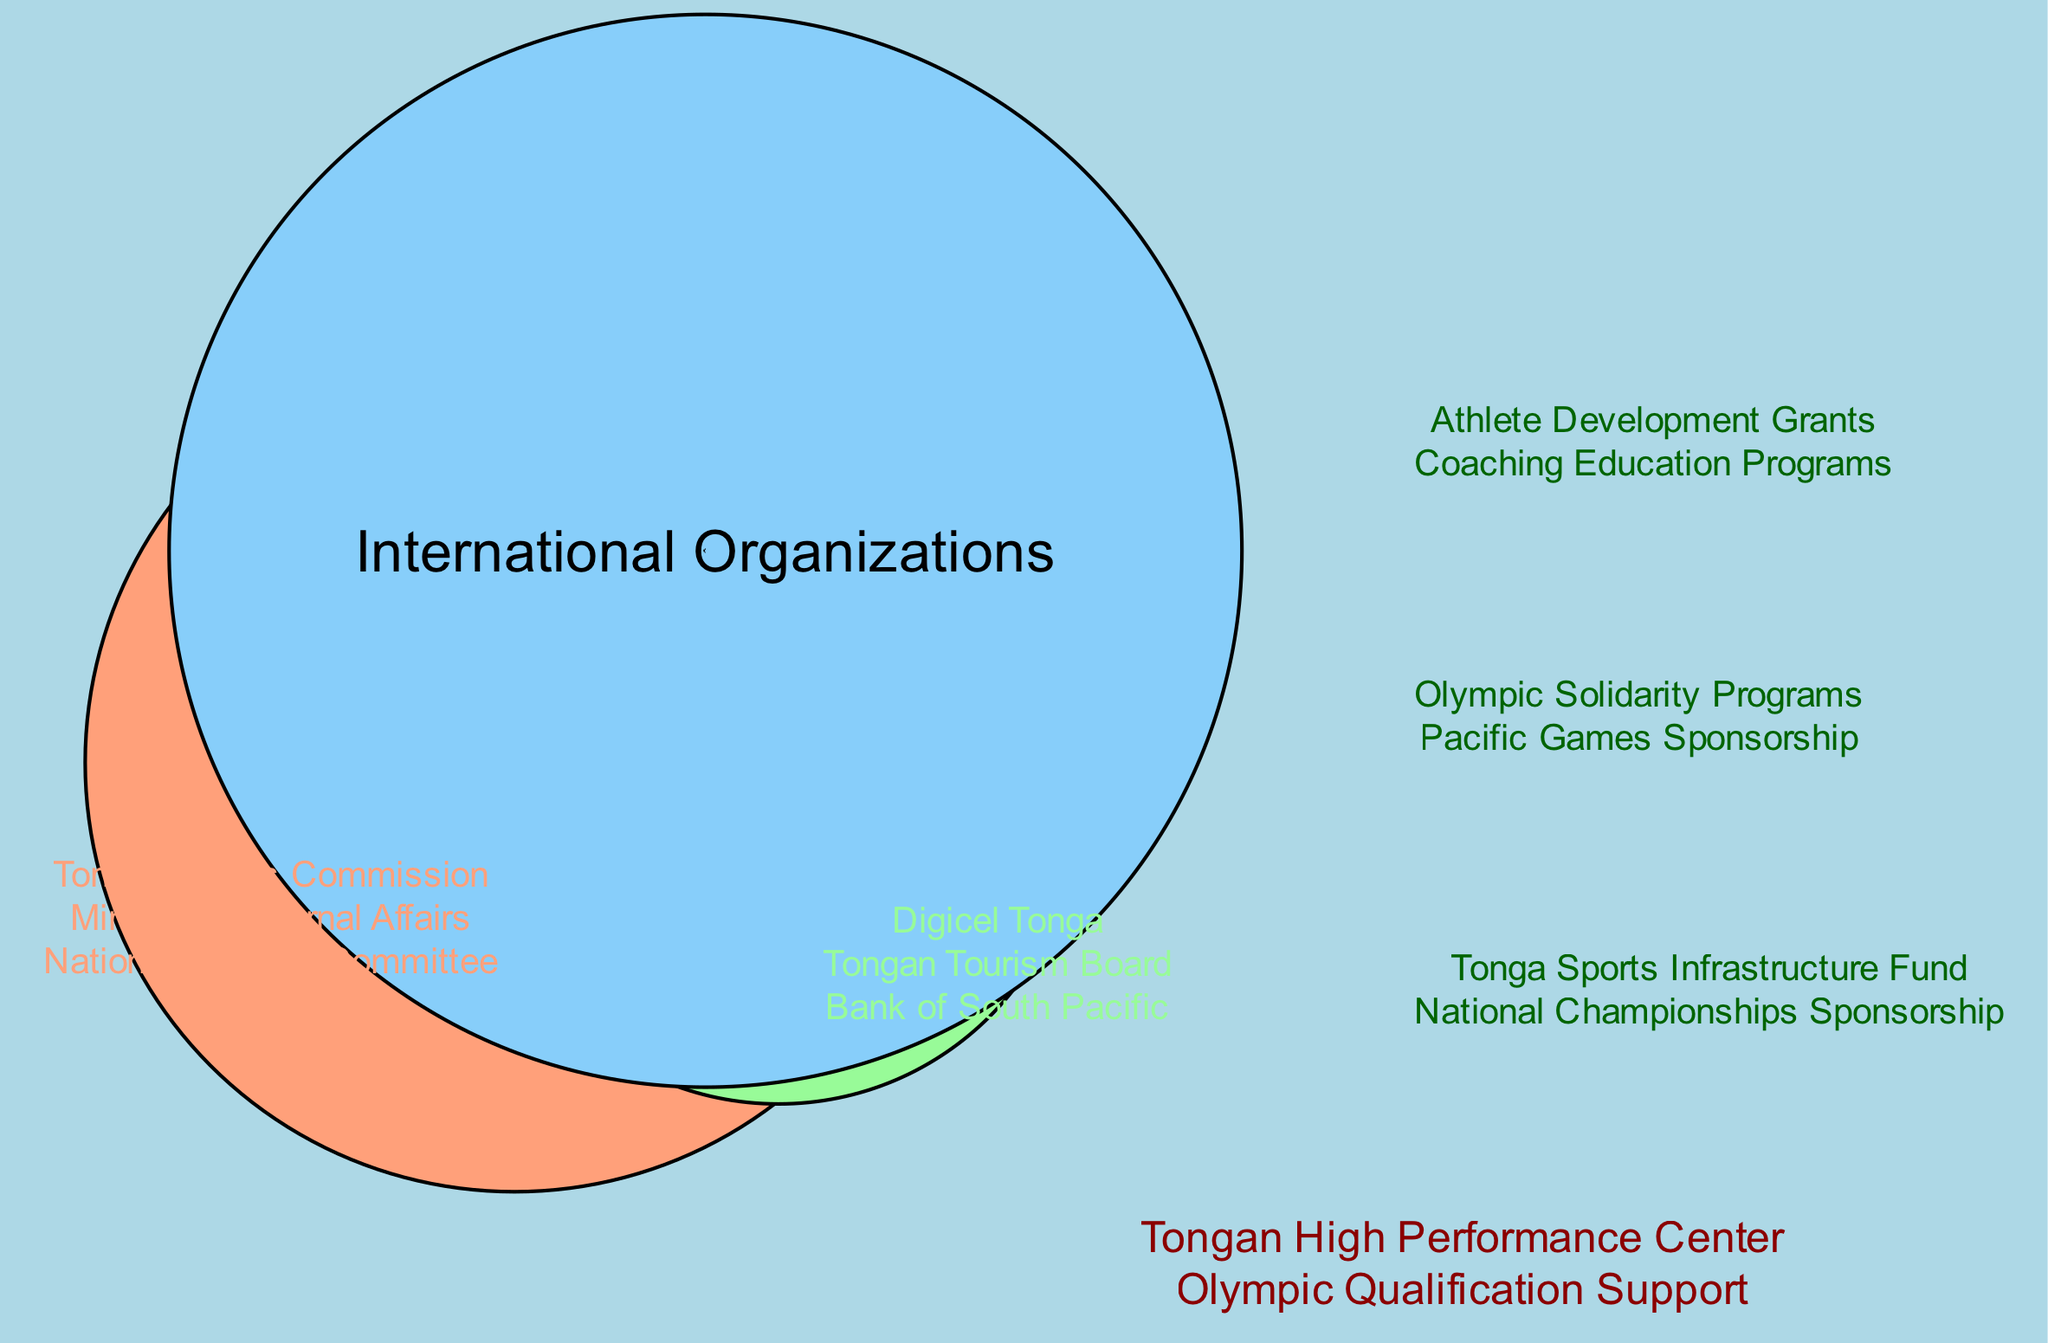What are the main sources of funding for Tongan sports programs? The diagram clearly defines three main funding sources: Government Funding, Private Sector, and International Organizations. This information is represented by separate circles in the Venn diagram.
Answer: Government Funding, Private Sector, International Organizations How many elements are listed under Government Funding? By reviewing the elements under the "Government Funding" circle, we can count that there are three specific elements mentioned: Tongan Sports Commission, Ministry of Internal Affairs, and National Olympic Committee.
Answer: 3 What is one element that is common in both Government Funding and International Organizations? The intersection between "Government Funding" and "International Organizations" includes two elements. One of them is "Athlete Development Grants," which shows the collaboration between these two funding sources.
Answer: Athlete Development Grants What are the two elements in the intersection between Private Sector and International Organizations? The overlap between the "Private Sector" and "International Organizations" circles includes the elements listed specifically for that intersection: "Olympic Solidarity Programs" and "Pacific Games Sponsorship." By analyzing the intersection area, we find these two elements.
Answer: Olympic Solidarity Programs, Pacific Games Sponsorship How many total elements are there in the intersection of all three sources? The center area of the Venn diagram, which represents the intersection of all three sets—Government Funding, Private Sector, and International Organizations—contains two elements. By enumerating the elements there, we can confirm this number.
Answer: 2 Which entity appears in the Private Sector circle? Looking at the "Private Sector" section, we identify the entities listed. One of the elements is "Digicel Tonga," which clearly falls under the Private Sector funding category.
Answer: Digicel Tonga What unique role does the Tongan High Performance Center play? Referencing the center area that overlaps all three funding sources, we see "Tongan High Performance Center," which indicates its importance as a collaborative effort supported by Government, Private Sector, and International Organizations alike.
Answer: Collaborative effort 